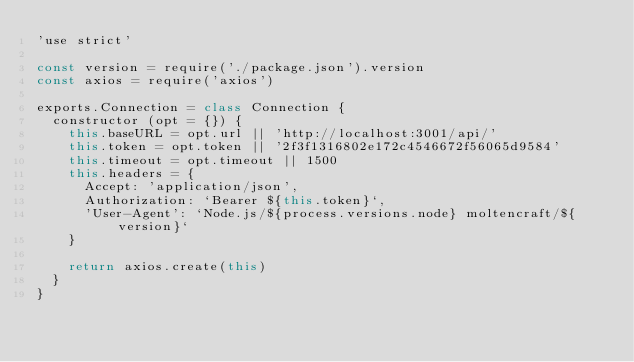Convert code to text. <code><loc_0><loc_0><loc_500><loc_500><_JavaScript_>'use strict'

const version = require('./package.json').version
const axios = require('axios')

exports.Connection = class Connection {
  constructor (opt = {}) {
    this.baseURL = opt.url || 'http://localhost:3001/api/'
    this.token = opt.token || '2f3f1316802e172c4546672f56065d9584'
    this.timeout = opt.timeout || 1500
    this.headers = {
      Accept: 'application/json',
      Authorization: `Bearer ${this.token}`,
      'User-Agent': `Node.js/${process.versions.node} moltencraft/${version}`
    }

    return axios.create(this)
  }
}
</code> 